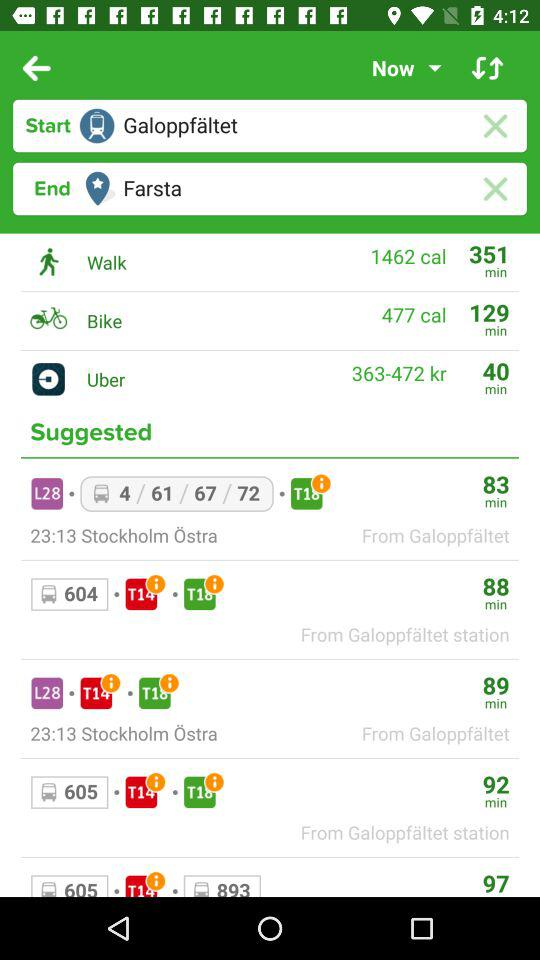How many calories are burned going by bike? Going by bike burns 477 calories. 